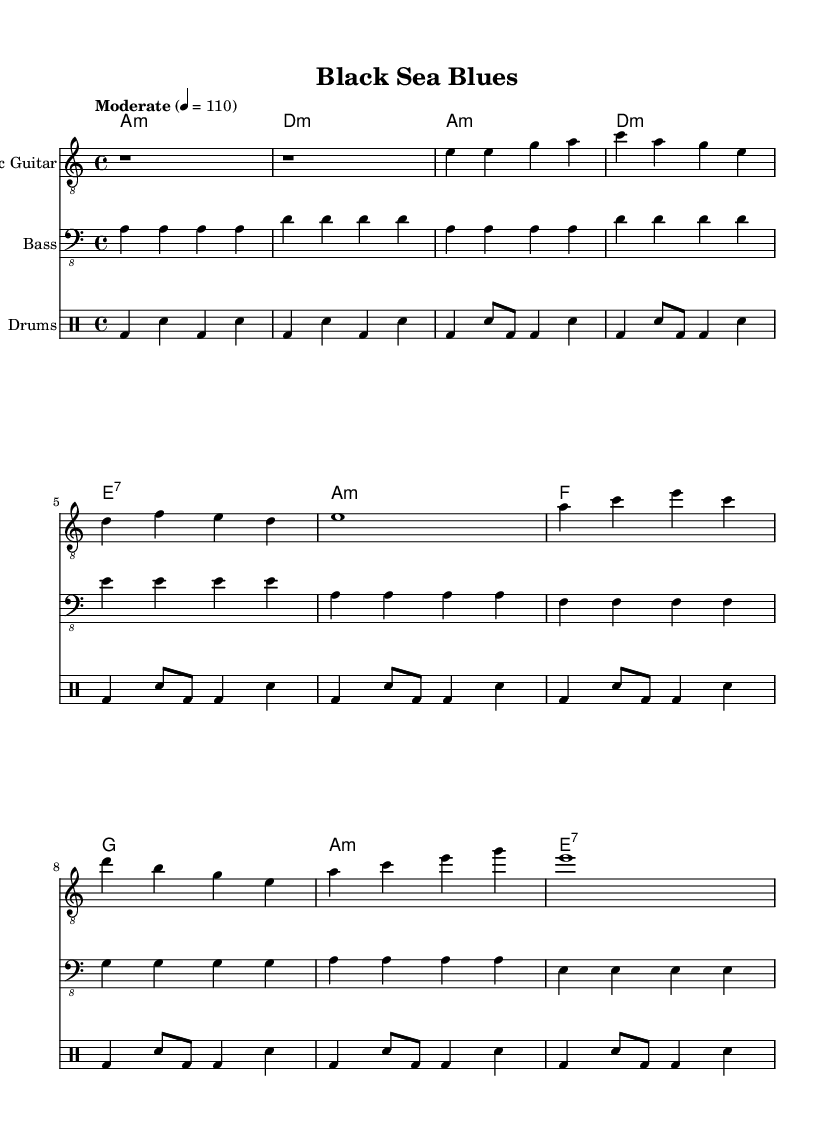What is the key signature of this music? The key signature is indicated by the placement of sharps or flats at the beginning of the staff. In this case, there are no sharps or flats, and it is indicated as A minor.
Answer: A minor What is the time signature of this music? The time signature is shown at the beginning of the staff and indicates how many beats are in each measure. Here, it says 4/4, meaning there are four beats in each measure.
Answer: 4/4 What is the tempo marking for this piece? The tempo marking is located at the beginning of the score and indicates the speed at which the piece should be played. It states "Moderate" with a metronome mark of 110 beats per minute.
Answer: 110 What chord follows the A minor chord in the verse? The chords are written in the chord part and follow a specific progression. After A minor, the next chord is D minor.
Answer: D minor Which section includes a change in dynamics? To determine sections involving dynamics, we analyze the score for indications of changes, which are typically expressed through markings such as crescendo or forte. In this excerpt, there are no specific dynamic markings shown, indicating no changes.
Answer: None What is the characteristic structure of Electric Blues shown in this music? Electric Blues typically uses a twelve-bar format characterized by repeated chord progressions. The score shows a common form with verses and choruses that reflect this structure, particularly in the way the chords are repeated across sections.
Answer: Verse and Chorus structure 